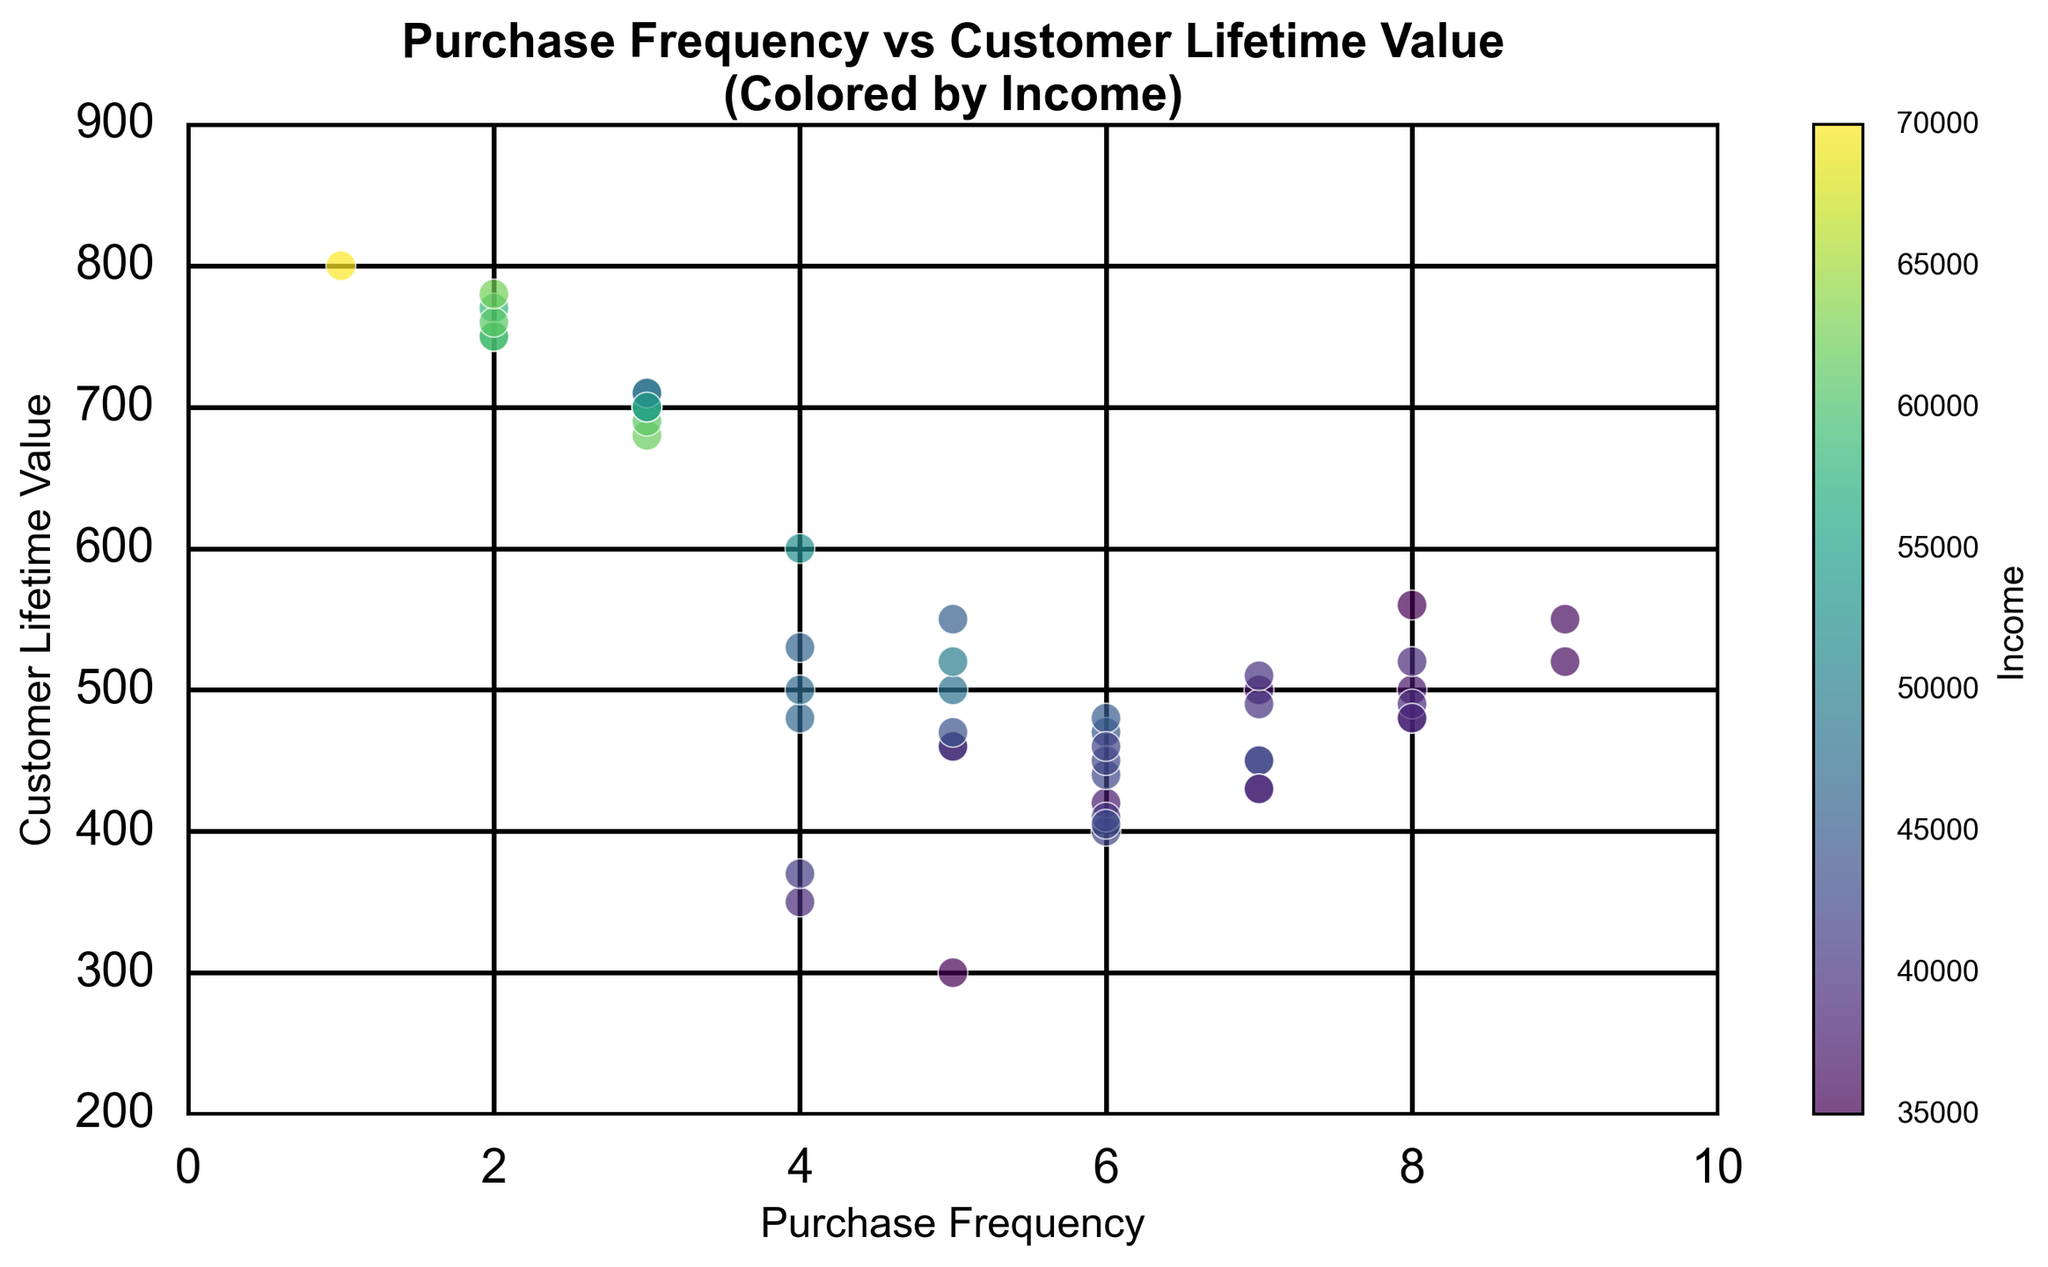What is the highest Customer Lifetime Value (CLV) associated with the highest Purchase Frequency? Identify the data point with the highest Purchase Frequency, then check the CLV value associated with it. The highest Purchase Frequency is 9, and the corresponding highest CLV is marked.
Answer: 550 Is there a noticeable trend between Purchase Frequency and Lifetime Value as Income increases? Observe the scatter plot to see if clusters or trends emerge as the color intensity (representing Income) changes. Notice how higher incomes correlate with higher CLV but not necessarily higher Purchase Frequency.
Answer: Higher incomes tend to correlate with higher CLV Among customers with a Purchase Frequency of 7, who has the highest Lifetime Value? Find all the data points where Purchase Frequency is 7. Then compare their CLV values to identify the highest one.
Answer: 510 Do male customers have generally higher CLV compared to female customers? Determine the average CLV for both male and female groups by looking at the scatter plot and grouping the colors representing gender. Compare the averages.
Answer: Yes What is the most common Income range for customers with a Purchase Frequency of 5? Look at the scatter plot points corresponding to a Purchase Frequency of 5 and note their corresponding color shades representing Income. Identify the most common shade.
Answer: 35000-45000 